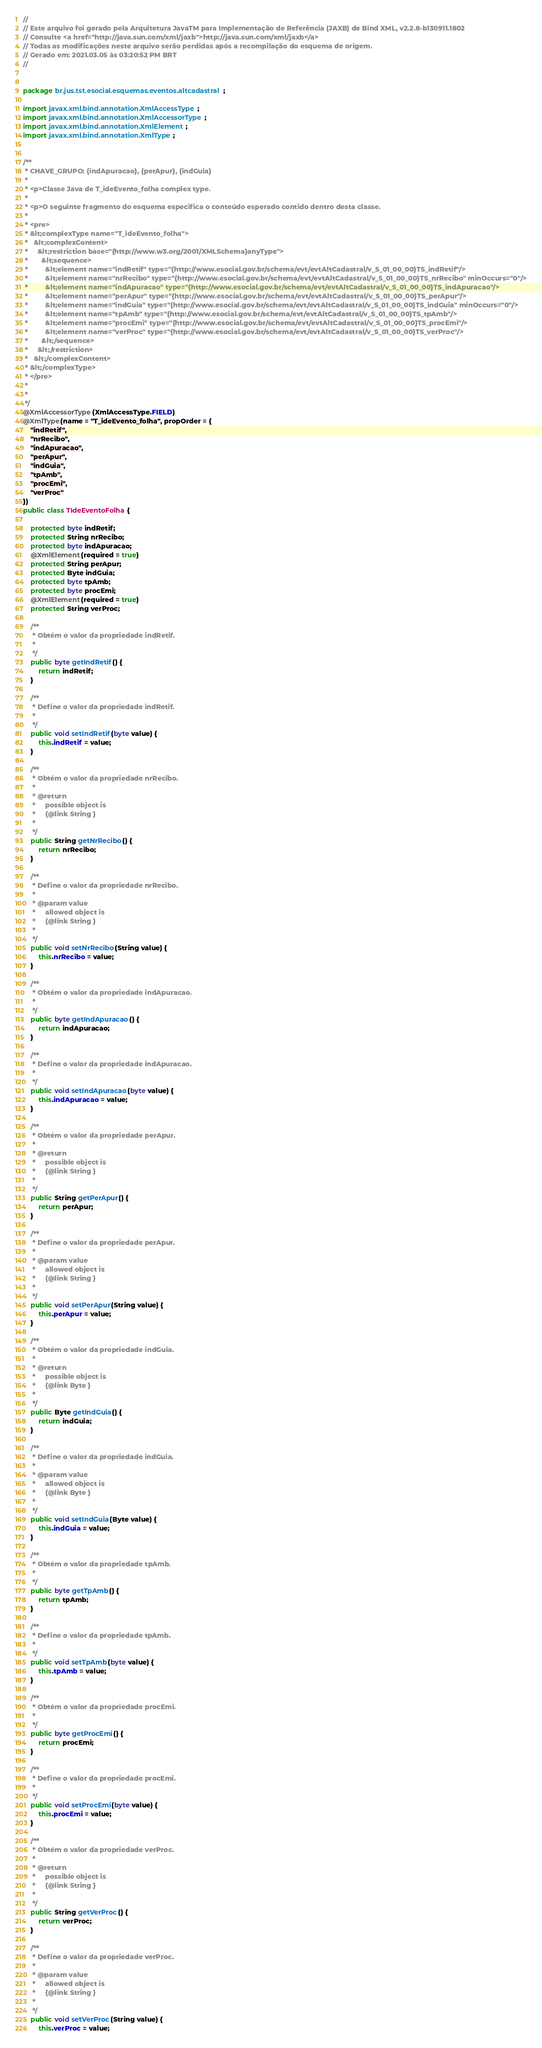Convert code to text. <code><loc_0><loc_0><loc_500><loc_500><_Java_>//
// Este arquivo foi gerado pela Arquitetura JavaTM para Implementação de Referência (JAXB) de Bind XML, v2.2.8-b130911.1802 
// Consulte <a href="http://java.sun.com/xml/jaxb">http://java.sun.com/xml/jaxb</a> 
// Todas as modificações neste arquivo serão perdidas após a recompilação do esquema de origem. 
// Gerado em: 2021.03.05 às 03:20:52 PM BRT 
//


package br.jus.tst.esocial.esquemas.eventos.altcadastral;

import javax.xml.bind.annotation.XmlAccessType;
import javax.xml.bind.annotation.XmlAccessorType;
import javax.xml.bind.annotation.XmlElement;
import javax.xml.bind.annotation.XmlType;


/**
 * CHAVE_GRUPO: {indApuracao}, {perApur}, {indGuia}
 * 
 * <p>Classe Java de T_ideEvento_folha complex type.
 * 
 * <p>O seguinte fragmento do esquema especifica o conteúdo esperado contido dentro desta classe.
 * 
 * <pre>
 * &lt;complexType name="T_ideEvento_folha">
 *   &lt;complexContent>
 *     &lt;restriction base="{http://www.w3.org/2001/XMLSchema}anyType">
 *       &lt;sequence>
 *         &lt;element name="indRetif" type="{http://www.esocial.gov.br/schema/evt/evtAltCadastral/v_S_01_00_00}TS_indRetif"/>
 *         &lt;element name="nrRecibo" type="{http://www.esocial.gov.br/schema/evt/evtAltCadastral/v_S_01_00_00}TS_nrRecibo" minOccurs="0"/>
 *         &lt;element name="indApuracao" type="{http://www.esocial.gov.br/schema/evt/evtAltCadastral/v_S_01_00_00}TS_indApuracao"/>
 *         &lt;element name="perApur" type="{http://www.esocial.gov.br/schema/evt/evtAltCadastral/v_S_01_00_00}TS_perApur"/>
 *         &lt;element name="indGuia" type="{http://www.esocial.gov.br/schema/evt/evtAltCadastral/v_S_01_00_00}TS_indGuia" minOccurs="0"/>
 *         &lt;element name="tpAmb" type="{http://www.esocial.gov.br/schema/evt/evtAltCadastral/v_S_01_00_00}TS_tpAmb"/>
 *         &lt;element name="procEmi" type="{http://www.esocial.gov.br/schema/evt/evtAltCadastral/v_S_01_00_00}TS_procEmi"/>
 *         &lt;element name="verProc" type="{http://www.esocial.gov.br/schema/evt/evtAltCadastral/v_S_01_00_00}TS_verProc"/>
 *       &lt;/sequence>
 *     &lt;/restriction>
 *   &lt;/complexContent>
 * &lt;/complexType>
 * </pre>
 * 
 * 
 */
@XmlAccessorType(XmlAccessType.FIELD)
@XmlType(name = "T_ideEvento_folha", propOrder = {
    "indRetif",
    "nrRecibo",
    "indApuracao",
    "perApur",
    "indGuia",
    "tpAmb",
    "procEmi",
    "verProc"
})
public class TIdeEventoFolha {

    protected byte indRetif;
    protected String nrRecibo;
    protected byte indApuracao;
    @XmlElement(required = true)
    protected String perApur;
    protected Byte indGuia;
    protected byte tpAmb;
    protected byte procEmi;
    @XmlElement(required = true)
    protected String verProc;

    /**
     * Obtém o valor da propriedade indRetif.
     * 
     */
    public byte getIndRetif() {
        return indRetif;
    }

    /**
     * Define o valor da propriedade indRetif.
     * 
     */
    public void setIndRetif(byte value) {
        this.indRetif = value;
    }

    /**
     * Obtém o valor da propriedade nrRecibo.
     * 
     * @return
     *     possible object is
     *     {@link String }
     *     
     */
    public String getNrRecibo() {
        return nrRecibo;
    }

    /**
     * Define o valor da propriedade nrRecibo.
     * 
     * @param value
     *     allowed object is
     *     {@link String }
     *     
     */
    public void setNrRecibo(String value) {
        this.nrRecibo = value;
    }

    /**
     * Obtém o valor da propriedade indApuracao.
     * 
     */
    public byte getIndApuracao() {
        return indApuracao;
    }

    /**
     * Define o valor da propriedade indApuracao.
     * 
     */
    public void setIndApuracao(byte value) {
        this.indApuracao = value;
    }

    /**
     * Obtém o valor da propriedade perApur.
     * 
     * @return
     *     possible object is
     *     {@link String }
     *     
     */
    public String getPerApur() {
        return perApur;
    }

    /**
     * Define o valor da propriedade perApur.
     * 
     * @param value
     *     allowed object is
     *     {@link String }
     *     
     */
    public void setPerApur(String value) {
        this.perApur = value;
    }

    /**
     * Obtém o valor da propriedade indGuia.
     * 
     * @return
     *     possible object is
     *     {@link Byte }
     *     
     */
    public Byte getIndGuia() {
        return indGuia;
    }

    /**
     * Define o valor da propriedade indGuia.
     * 
     * @param value
     *     allowed object is
     *     {@link Byte }
     *     
     */
    public void setIndGuia(Byte value) {
        this.indGuia = value;
    }

    /**
     * Obtém o valor da propriedade tpAmb.
     * 
     */
    public byte getTpAmb() {
        return tpAmb;
    }

    /**
     * Define o valor da propriedade tpAmb.
     * 
     */
    public void setTpAmb(byte value) {
        this.tpAmb = value;
    }

    /**
     * Obtém o valor da propriedade procEmi.
     * 
     */
    public byte getProcEmi() {
        return procEmi;
    }

    /**
     * Define o valor da propriedade procEmi.
     * 
     */
    public void setProcEmi(byte value) {
        this.procEmi = value;
    }

    /**
     * Obtém o valor da propriedade verProc.
     * 
     * @return
     *     possible object is
     *     {@link String }
     *     
     */
    public String getVerProc() {
        return verProc;
    }

    /**
     * Define o valor da propriedade verProc.
     * 
     * @param value
     *     allowed object is
     *     {@link String }
     *     
     */
    public void setVerProc(String value) {
        this.verProc = value;</code> 